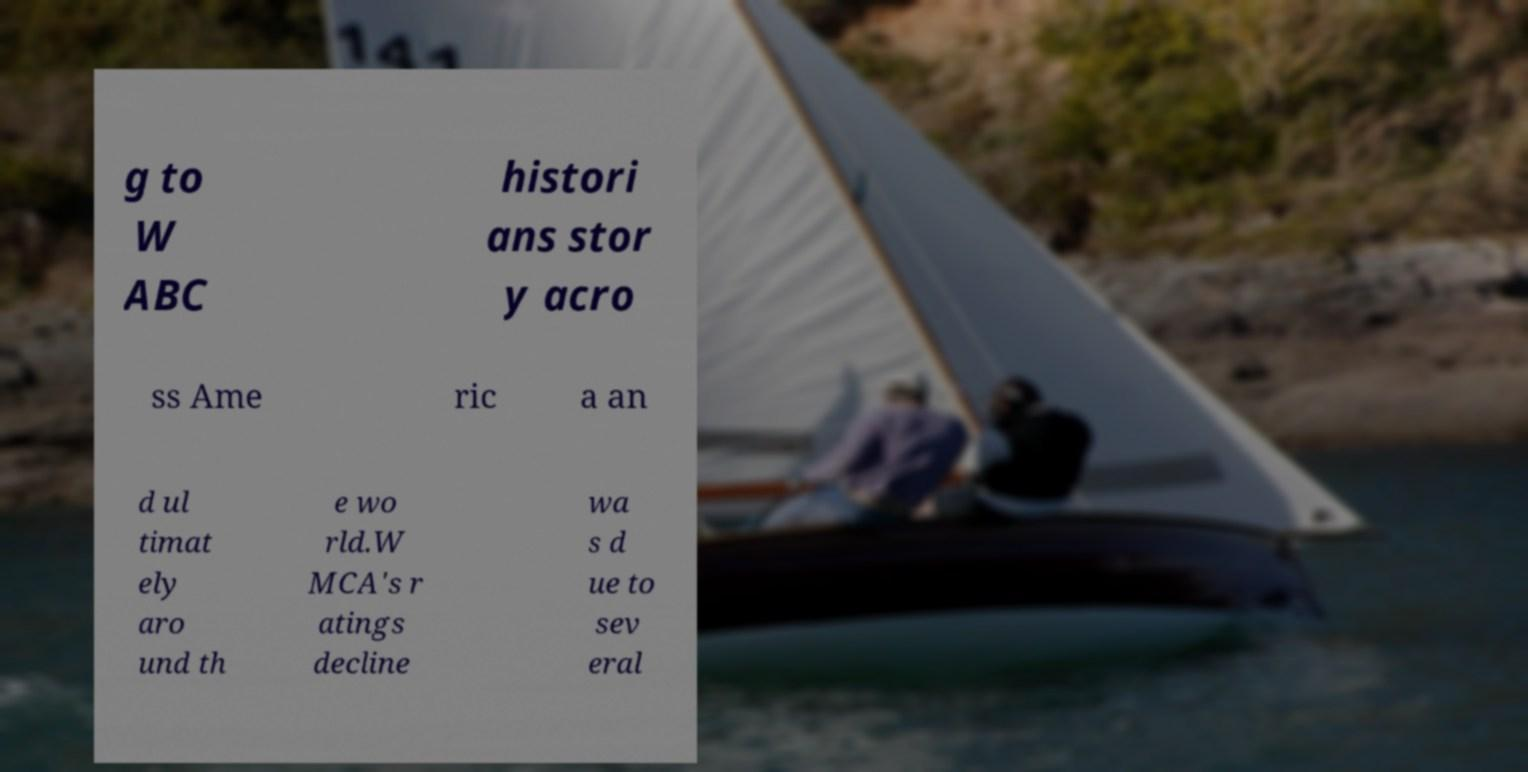Could you assist in decoding the text presented in this image and type it out clearly? g to W ABC histori ans stor y acro ss Ame ric a an d ul timat ely aro und th e wo rld.W MCA's r atings decline wa s d ue to sev eral 